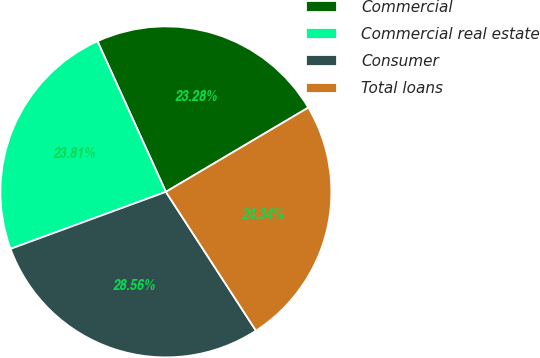Convert chart. <chart><loc_0><loc_0><loc_500><loc_500><pie_chart><fcel>Commercial<fcel>Commercial real estate<fcel>Consumer<fcel>Total loans<nl><fcel>23.28%<fcel>23.81%<fcel>28.56%<fcel>24.34%<nl></chart> 